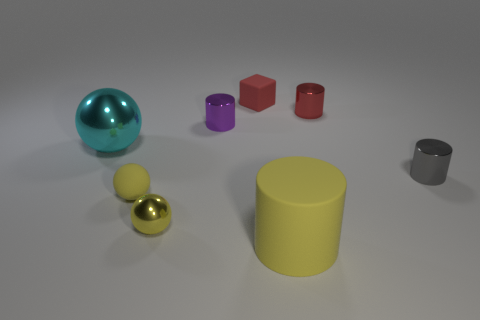Subtract all yellow cylinders. Subtract all purple spheres. How many cylinders are left? 3 Add 2 metal things. How many objects exist? 10 Subtract all balls. How many objects are left? 5 Subtract all tiny cyan metal cylinders. Subtract all small gray objects. How many objects are left? 7 Add 7 rubber blocks. How many rubber blocks are left? 8 Add 7 tiny rubber blocks. How many tiny rubber blocks exist? 8 Subtract 0 brown blocks. How many objects are left? 8 